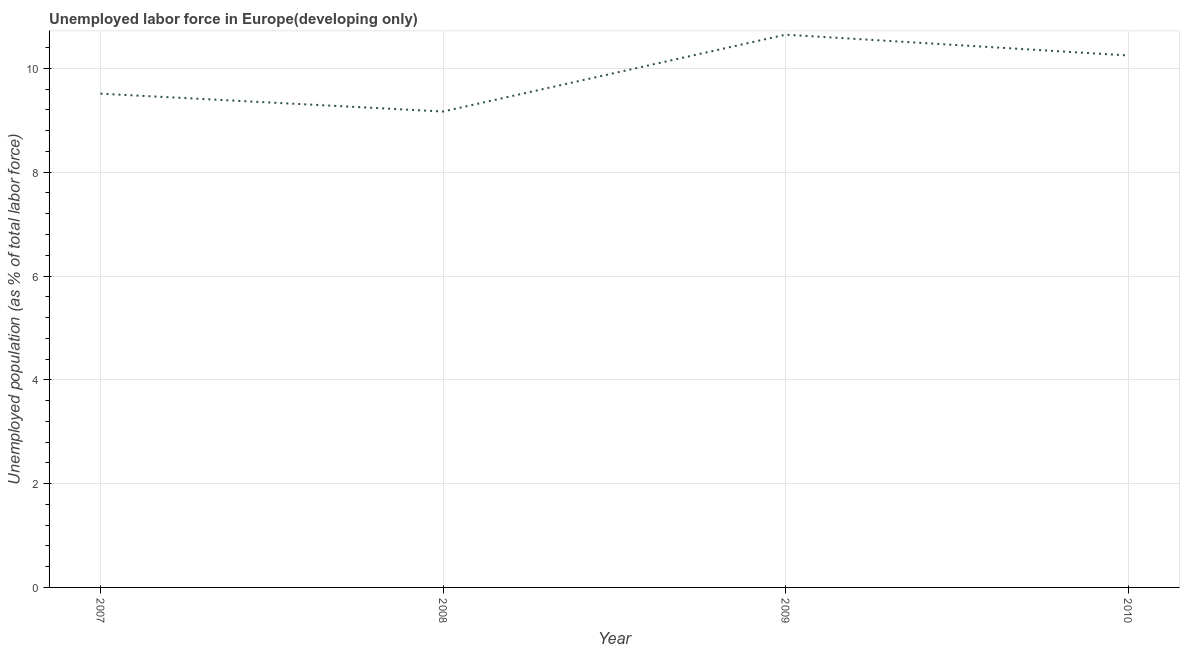What is the total unemployed population in 2007?
Offer a terse response. 9.51. Across all years, what is the maximum total unemployed population?
Keep it short and to the point. 10.65. Across all years, what is the minimum total unemployed population?
Offer a terse response. 9.17. In which year was the total unemployed population maximum?
Your response must be concise. 2009. In which year was the total unemployed population minimum?
Give a very brief answer. 2008. What is the sum of the total unemployed population?
Offer a terse response. 39.58. What is the difference between the total unemployed population in 2007 and 2008?
Offer a terse response. 0.34. What is the average total unemployed population per year?
Offer a terse response. 9.9. What is the median total unemployed population?
Give a very brief answer. 9.88. What is the ratio of the total unemployed population in 2007 to that in 2010?
Offer a terse response. 0.93. What is the difference between the highest and the second highest total unemployed population?
Your response must be concise. 0.4. Is the sum of the total unemployed population in 2009 and 2010 greater than the maximum total unemployed population across all years?
Your answer should be very brief. Yes. What is the difference between the highest and the lowest total unemployed population?
Your answer should be very brief. 1.48. Does the graph contain grids?
Give a very brief answer. Yes. What is the title of the graph?
Make the answer very short. Unemployed labor force in Europe(developing only). What is the label or title of the X-axis?
Your response must be concise. Year. What is the label or title of the Y-axis?
Provide a short and direct response. Unemployed population (as % of total labor force). What is the Unemployed population (as % of total labor force) of 2007?
Offer a terse response. 9.51. What is the Unemployed population (as % of total labor force) of 2008?
Make the answer very short. 9.17. What is the Unemployed population (as % of total labor force) of 2009?
Offer a very short reply. 10.65. What is the Unemployed population (as % of total labor force) in 2010?
Provide a short and direct response. 10.25. What is the difference between the Unemployed population (as % of total labor force) in 2007 and 2008?
Keep it short and to the point. 0.34. What is the difference between the Unemployed population (as % of total labor force) in 2007 and 2009?
Provide a succinct answer. -1.14. What is the difference between the Unemployed population (as % of total labor force) in 2007 and 2010?
Give a very brief answer. -0.74. What is the difference between the Unemployed population (as % of total labor force) in 2008 and 2009?
Ensure brevity in your answer.  -1.48. What is the difference between the Unemployed population (as % of total labor force) in 2008 and 2010?
Ensure brevity in your answer.  -1.08. What is the difference between the Unemployed population (as % of total labor force) in 2009 and 2010?
Provide a succinct answer. 0.4. What is the ratio of the Unemployed population (as % of total labor force) in 2007 to that in 2008?
Your response must be concise. 1.04. What is the ratio of the Unemployed population (as % of total labor force) in 2007 to that in 2009?
Provide a succinct answer. 0.89. What is the ratio of the Unemployed population (as % of total labor force) in 2007 to that in 2010?
Make the answer very short. 0.93. What is the ratio of the Unemployed population (as % of total labor force) in 2008 to that in 2009?
Provide a succinct answer. 0.86. What is the ratio of the Unemployed population (as % of total labor force) in 2008 to that in 2010?
Your answer should be compact. 0.9. What is the ratio of the Unemployed population (as % of total labor force) in 2009 to that in 2010?
Make the answer very short. 1.04. 